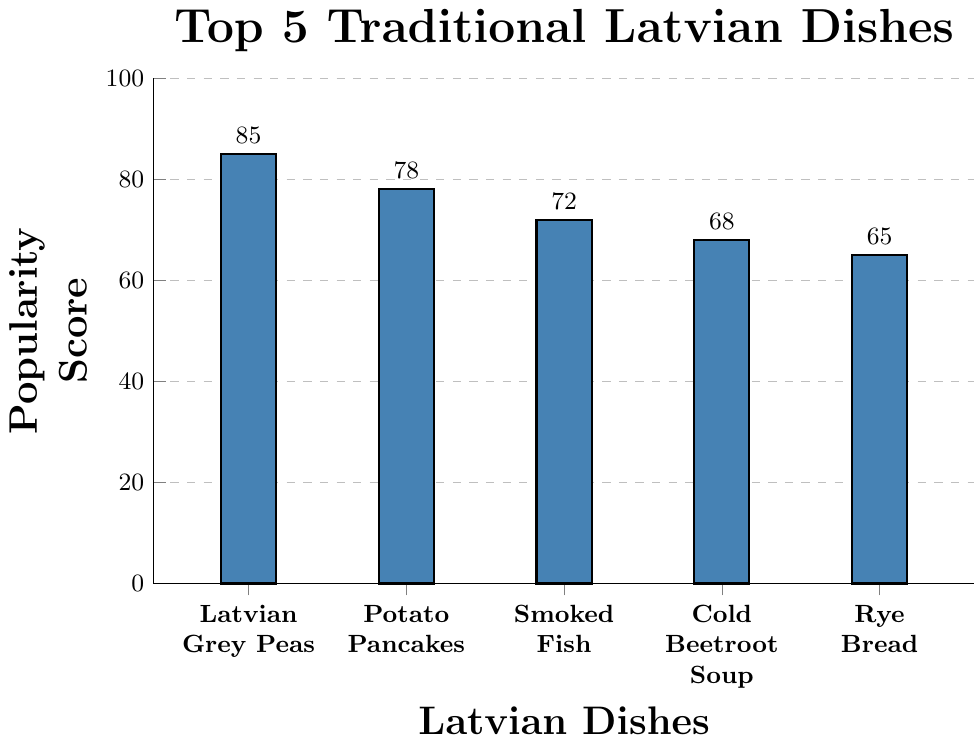Which dish has the highest popularity score among international tourists? The highest bar in the bar chart represents the dish with the highest popularity score. In this case, the bar for "Latvian Grey Peas" is the highest.
Answer: Latvian Grey Peas How many more points does Potato Pancakes have compared to Smoked Fish? To find the difference in popularity scores, subtract the score for Smoked Fish from that of Potato Pancakes: 78 (Potato Pancakes) - 72 (Smoked Fish) = 6.
Answer: 6 points Which dish ranks fifth in terms of popularity score? The fifth bar from the left corresponds to the dish ranked fifth in terms of popularity, which is Rye Bread with a score of 65.
Answer: Rye Bread What is the total popularity score of the top three dishes combined? Sum the popularity scores of the top three dishes: 85 (Latvian Grey Peas) + 78 (Potato Pancakes) + 72 (Smoked Fish) = 235.
Answer: 235 Which two dishes have a combined popularity score closest to 150? Calculate the combined scores of different pairs of dishes. The pairs (Latvian Grey Peas and Cold Beetroot Soup) have a combined score of 85 + 68 = 153, which is closest to 150.
Answer: Latvian Grey Peas and Cold Beetroot Soup Between Cold Beetroot Soup and Rye Bread, which dish is more popular? Compare the heights of the bars for Cold Beetroot Soup (68) and Rye Bread (65). Cold Beetroot Soup has a higher score.
Answer: Cold Beetroot Soup How much less popular is Rye Bread compared to Latvian Grey Peas? To find the difference, subtract the popularity score of Rye Bread from that of Latvian Grey Peas: 85 (Latvian Grey Peas) - 65 (Rye Bread) = 20.
Answer: 20 points What's the average popularity score of the top 5 dishes? Add the popularity scores of the top 5 dishes and divide by 5: (85 + 78 + 72 + 68 + 65) / 5 = 368 / 5 = 73.6.
Answer: 73.6 